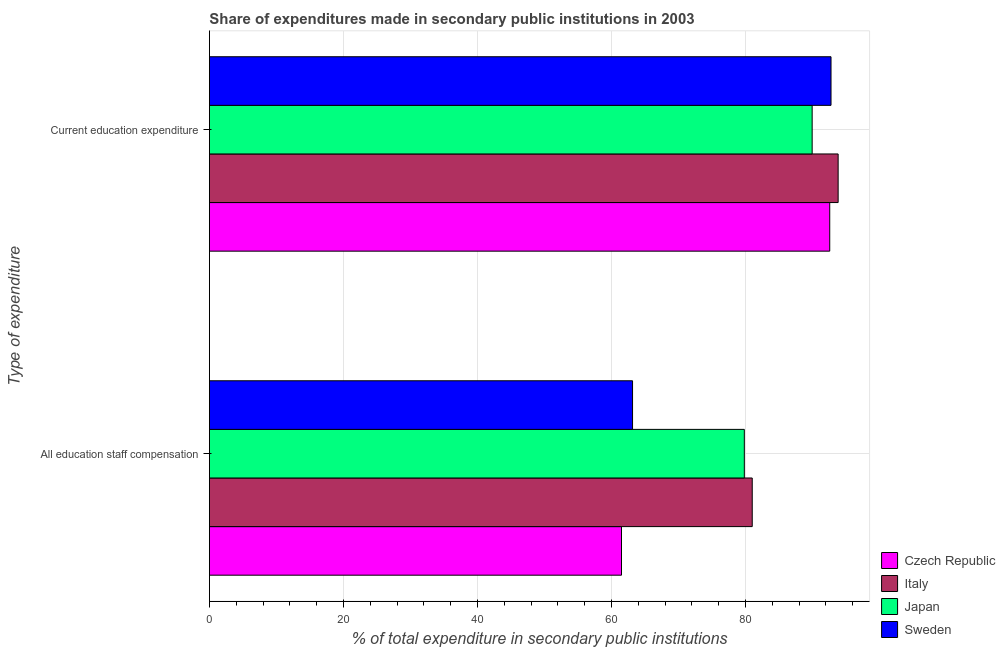How many groups of bars are there?
Provide a succinct answer. 2. Are the number of bars per tick equal to the number of legend labels?
Keep it short and to the point. Yes. How many bars are there on the 1st tick from the bottom?
Offer a very short reply. 4. What is the label of the 1st group of bars from the top?
Provide a succinct answer. Current education expenditure. What is the expenditure in education in Italy?
Your response must be concise. 93.82. Across all countries, what is the maximum expenditure in education?
Keep it short and to the point. 93.82. Across all countries, what is the minimum expenditure in staff compensation?
Provide a short and direct response. 61.49. In which country was the expenditure in education minimum?
Offer a very short reply. Japan. What is the total expenditure in staff compensation in the graph?
Your answer should be compact. 285.46. What is the difference between the expenditure in staff compensation in Italy and that in Sweden?
Your response must be concise. 17.86. What is the difference between the expenditure in staff compensation in Sweden and the expenditure in education in Japan?
Ensure brevity in your answer.  -26.8. What is the average expenditure in education per country?
Your answer should be compact. 92.27. What is the difference between the expenditure in staff compensation and expenditure in education in Italy?
Give a very brief answer. -12.82. In how many countries, is the expenditure in staff compensation greater than 28 %?
Provide a short and direct response. 4. What is the ratio of the expenditure in education in Japan to that in Sweden?
Offer a very short reply. 0.97. What does the 1st bar from the top in All education staff compensation represents?
Keep it short and to the point. Sweden. Are all the bars in the graph horizontal?
Give a very brief answer. Yes. Does the graph contain any zero values?
Ensure brevity in your answer.  No. What is the title of the graph?
Ensure brevity in your answer.  Share of expenditures made in secondary public institutions in 2003. What is the label or title of the X-axis?
Keep it short and to the point. % of total expenditure in secondary public institutions. What is the label or title of the Y-axis?
Ensure brevity in your answer.  Type of expenditure. What is the % of total expenditure in secondary public institutions of Czech Republic in All education staff compensation?
Ensure brevity in your answer.  61.49. What is the % of total expenditure in secondary public institutions of Italy in All education staff compensation?
Offer a terse response. 81. What is the % of total expenditure in secondary public institutions of Japan in All education staff compensation?
Provide a succinct answer. 79.82. What is the % of total expenditure in secondary public institutions of Sweden in All education staff compensation?
Provide a short and direct response. 63.14. What is the % of total expenditure in secondary public institutions of Czech Republic in Current education expenditure?
Provide a short and direct response. 92.57. What is the % of total expenditure in secondary public institutions in Italy in Current education expenditure?
Make the answer very short. 93.82. What is the % of total expenditure in secondary public institutions of Japan in Current education expenditure?
Keep it short and to the point. 89.94. What is the % of total expenditure in secondary public institutions in Sweden in Current education expenditure?
Provide a short and direct response. 92.76. Across all Type of expenditure, what is the maximum % of total expenditure in secondary public institutions in Czech Republic?
Give a very brief answer. 92.57. Across all Type of expenditure, what is the maximum % of total expenditure in secondary public institutions of Italy?
Ensure brevity in your answer.  93.82. Across all Type of expenditure, what is the maximum % of total expenditure in secondary public institutions in Japan?
Make the answer very short. 89.94. Across all Type of expenditure, what is the maximum % of total expenditure in secondary public institutions in Sweden?
Ensure brevity in your answer.  92.76. Across all Type of expenditure, what is the minimum % of total expenditure in secondary public institutions of Czech Republic?
Ensure brevity in your answer.  61.49. Across all Type of expenditure, what is the minimum % of total expenditure in secondary public institutions of Italy?
Ensure brevity in your answer.  81. Across all Type of expenditure, what is the minimum % of total expenditure in secondary public institutions in Japan?
Make the answer very short. 79.82. Across all Type of expenditure, what is the minimum % of total expenditure in secondary public institutions of Sweden?
Your answer should be very brief. 63.14. What is the total % of total expenditure in secondary public institutions of Czech Republic in the graph?
Ensure brevity in your answer.  154.06. What is the total % of total expenditure in secondary public institutions of Italy in the graph?
Ensure brevity in your answer.  174.82. What is the total % of total expenditure in secondary public institutions in Japan in the graph?
Make the answer very short. 169.77. What is the total % of total expenditure in secondary public institutions of Sweden in the graph?
Ensure brevity in your answer.  155.9. What is the difference between the % of total expenditure in secondary public institutions of Czech Republic in All education staff compensation and that in Current education expenditure?
Give a very brief answer. -31.08. What is the difference between the % of total expenditure in secondary public institutions of Italy in All education staff compensation and that in Current education expenditure?
Give a very brief answer. -12.82. What is the difference between the % of total expenditure in secondary public institutions in Japan in All education staff compensation and that in Current education expenditure?
Provide a short and direct response. -10.12. What is the difference between the % of total expenditure in secondary public institutions in Sweden in All education staff compensation and that in Current education expenditure?
Your response must be concise. -29.62. What is the difference between the % of total expenditure in secondary public institutions in Czech Republic in All education staff compensation and the % of total expenditure in secondary public institutions in Italy in Current education expenditure?
Your answer should be compact. -32.33. What is the difference between the % of total expenditure in secondary public institutions of Czech Republic in All education staff compensation and the % of total expenditure in secondary public institutions of Japan in Current education expenditure?
Your response must be concise. -28.45. What is the difference between the % of total expenditure in secondary public institutions in Czech Republic in All education staff compensation and the % of total expenditure in secondary public institutions in Sweden in Current education expenditure?
Give a very brief answer. -31.27. What is the difference between the % of total expenditure in secondary public institutions of Italy in All education staff compensation and the % of total expenditure in secondary public institutions of Japan in Current education expenditure?
Offer a terse response. -8.94. What is the difference between the % of total expenditure in secondary public institutions in Italy in All education staff compensation and the % of total expenditure in secondary public institutions in Sweden in Current education expenditure?
Your answer should be compact. -11.76. What is the difference between the % of total expenditure in secondary public institutions in Japan in All education staff compensation and the % of total expenditure in secondary public institutions in Sweden in Current education expenditure?
Ensure brevity in your answer.  -12.94. What is the average % of total expenditure in secondary public institutions in Czech Republic per Type of expenditure?
Offer a very short reply. 77.03. What is the average % of total expenditure in secondary public institutions of Italy per Type of expenditure?
Your answer should be compact. 87.41. What is the average % of total expenditure in secondary public institutions in Japan per Type of expenditure?
Your answer should be compact. 84.88. What is the average % of total expenditure in secondary public institutions of Sweden per Type of expenditure?
Give a very brief answer. 77.95. What is the difference between the % of total expenditure in secondary public institutions of Czech Republic and % of total expenditure in secondary public institutions of Italy in All education staff compensation?
Offer a very short reply. -19.51. What is the difference between the % of total expenditure in secondary public institutions of Czech Republic and % of total expenditure in secondary public institutions of Japan in All education staff compensation?
Provide a succinct answer. -18.33. What is the difference between the % of total expenditure in secondary public institutions of Czech Republic and % of total expenditure in secondary public institutions of Sweden in All education staff compensation?
Provide a succinct answer. -1.65. What is the difference between the % of total expenditure in secondary public institutions of Italy and % of total expenditure in secondary public institutions of Japan in All education staff compensation?
Your answer should be very brief. 1.18. What is the difference between the % of total expenditure in secondary public institutions in Italy and % of total expenditure in secondary public institutions in Sweden in All education staff compensation?
Your answer should be compact. 17.86. What is the difference between the % of total expenditure in secondary public institutions in Japan and % of total expenditure in secondary public institutions in Sweden in All education staff compensation?
Give a very brief answer. 16.68. What is the difference between the % of total expenditure in secondary public institutions in Czech Republic and % of total expenditure in secondary public institutions in Italy in Current education expenditure?
Your answer should be compact. -1.25. What is the difference between the % of total expenditure in secondary public institutions in Czech Republic and % of total expenditure in secondary public institutions in Japan in Current education expenditure?
Keep it short and to the point. 2.62. What is the difference between the % of total expenditure in secondary public institutions of Czech Republic and % of total expenditure in secondary public institutions of Sweden in Current education expenditure?
Offer a very short reply. -0.19. What is the difference between the % of total expenditure in secondary public institutions in Italy and % of total expenditure in secondary public institutions in Japan in Current education expenditure?
Give a very brief answer. 3.88. What is the difference between the % of total expenditure in secondary public institutions in Italy and % of total expenditure in secondary public institutions in Sweden in Current education expenditure?
Offer a terse response. 1.06. What is the difference between the % of total expenditure in secondary public institutions in Japan and % of total expenditure in secondary public institutions in Sweden in Current education expenditure?
Provide a succinct answer. -2.82. What is the ratio of the % of total expenditure in secondary public institutions of Czech Republic in All education staff compensation to that in Current education expenditure?
Make the answer very short. 0.66. What is the ratio of the % of total expenditure in secondary public institutions in Italy in All education staff compensation to that in Current education expenditure?
Make the answer very short. 0.86. What is the ratio of the % of total expenditure in secondary public institutions of Japan in All education staff compensation to that in Current education expenditure?
Offer a terse response. 0.89. What is the ratio of the % of total expenditure in secondary public institutions in Sweden in All education staff compensation to that in Current education expenditure?
Offer a very short reply. 0.68. What is the difference between the highest and the second highest % of total expenditure in secondary public institutions in Czech Republic?
Provide a succinct answer. 31.08. What is the difference between the highest and the second highest % of total expenditure in secondary public institutions in Italy?
Your answer should be very brief. 12.82. What is the difference between the highest and the second highest % of total expenditure in secondary public institutions of Japan?
Give a very brief answer. 10.12. What is the difference between the highest and the second highest % of total expenditure in secondary public institutions in Sweden?
Provide a short and direct response. 29.62. What is the difference between the highest and the lowest % of total expenditure in secondary public institutions of Czech Republic?
Your answer should be compact. 31.08. What is the difference between the highest and the lowest % of total expenditure in secondary public institutions in Italy?
Offer a terse response. 12.82. What is the difference between the highest and the lowest % of total expenditure in secondary public institutions in Japan?
Give a very brief answer. 10.12. What is the difference between the highest and the lowest % of total expenditure in secondary public institutions in Sweden?
Provide a short and direct response. 29.62. 